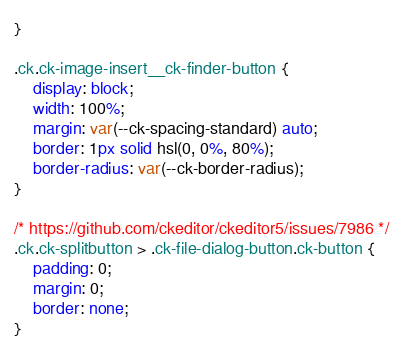Convert code to text. <code><loc_0><loc_0><loc_500><loc_500><_CSS_>}

.ck.ck-image-insert__ck-finder-button {
	display: block;
	width: 100%;
	margin: var(--ck-spacing-standard) auto;
	border: 1px solid hsl(0, 0%, 80%);
	border-radius: var(--ck-border-radius);
}

/* https://github.com/ckeditor/ckeditor5/issues/7986 */
.ck.ck-splitbutton > .ck-file-dialog-button.ck-button {
	padding: 0;
	margin: 0;
	border: none;
}
</code> 